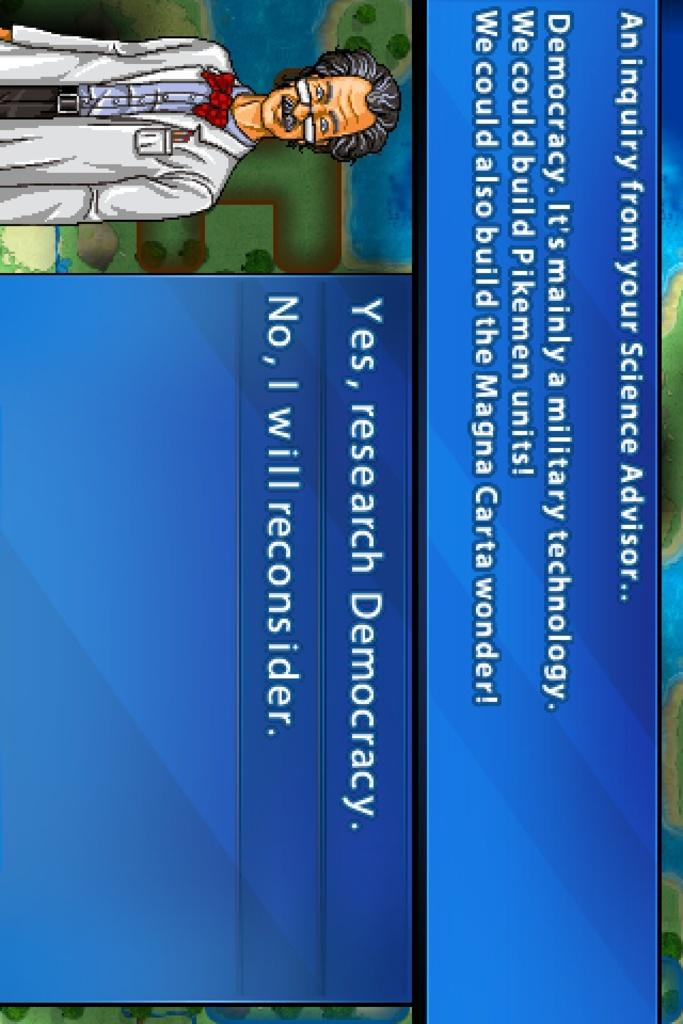<image>
Relay a brief, clear account of the picture shown. A monitor displays a blue screen with the first line reading, "an inquiry from your Science Advisor." 